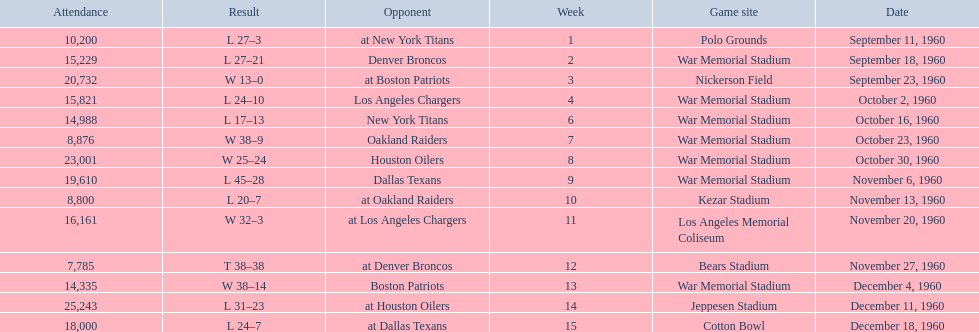Parse the full table. {'header': ['Attendance', 'Result', 'Opponent', 'Week', 'Game site', 'Date'], 'rows': [['10,200', 'L 27–3', 'at New York Titans', '1', 'Polo Grounds', 'September 11, 1960'], ['15,229', 'L 27–21', 'Denver Broncos', '2', 'War Memorial Stadium', 'September 18, 1960'], ['20,732', 'W 13–0', 'at Boston Patriots', '3', 'Nickerson Field', 'September 23, 1960'], ['15,821', 'L 24–10', 'Los Angeles Chargers', '4', 'War Memorial Stadium', 'October 2, 1960'], ['14,988', 'L 17–13', 'New York Titans', '6', 'War Memorial Stadium', 'October 16, 1960'], ['8,876', 'W 38–9', 'Oakland Raiders', '7', 'War Memorial Stadium', 'October 23, 1960'], ['23,001', 'W 25–24', 'Houston Oilers', '8', 'War Memorial Stadium', 'October 30, 1960'], ['19,610', 'L 45–28', 'Dallas Texans', '9', 'War Memorial Stadium', 'November 6, 1960'], ['8,800', 'L 20–7', 'at Oakland Raiders', '10', 'Kezar Stadium', 'November 13, 1960'], ['16,161', 'W 32–3', 'at Los Angeles Chargers', '11', 'Los Angeles Memorial Coliseum', 'November 20, 1960'], ['7,785', 'T 38–38', 'at Denver Broncos', '12', 'Bears Stadium', 'November 27, 1960'], ['14,335', 'W 38–14', 'Boston Patriots', '13', 'War Memorial Stadium', 'December 4, 1960'], ['25,243', 'L 31–23', 'at Houston Oilers', '14', 'Jeppesen Stadium', 'December 11, 1960'], ['18,000', 'L 24–7', 'at Dallas Texans', '15', 'Cotton Bowl', 'December 18, 1960']]} What was the largest difference of points in a single game? 29. 